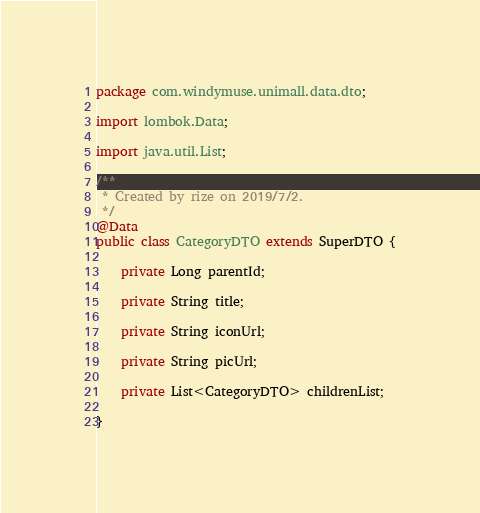Convert code to text. <code><loc_0><loc_0><loc_500><loc_500><_Java_>package com.windymuse.unimall.data.dto;

import lombok.Data;

import java.util.List;

/**
 * Created by rize on 2019/7/2.
 */
@Data
public class CategoryDTO extends SuperDTO {

    private Long parentId;

    private String title;

    private String iconUrl;

    private String picUrl;

    private List<CategoryDTO> childrenList;

}
</code> 